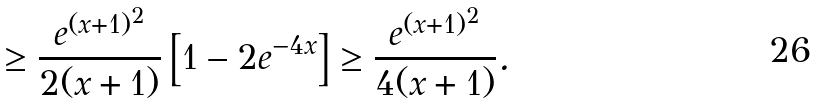<formula> <loc_0><loc_0><loc_500><loc_500>\geq \frac { e ^ { ( x + 1 ) ^ { 2 } } } { 2 ( x + 1 ) } \left [ 1 - 2 e ^ { - 4 x } \right ] \geq \frac { e ^ { ( x + 1 ) ^ { 2 } } } { 4 ( x + 1 ) } .</formula> 